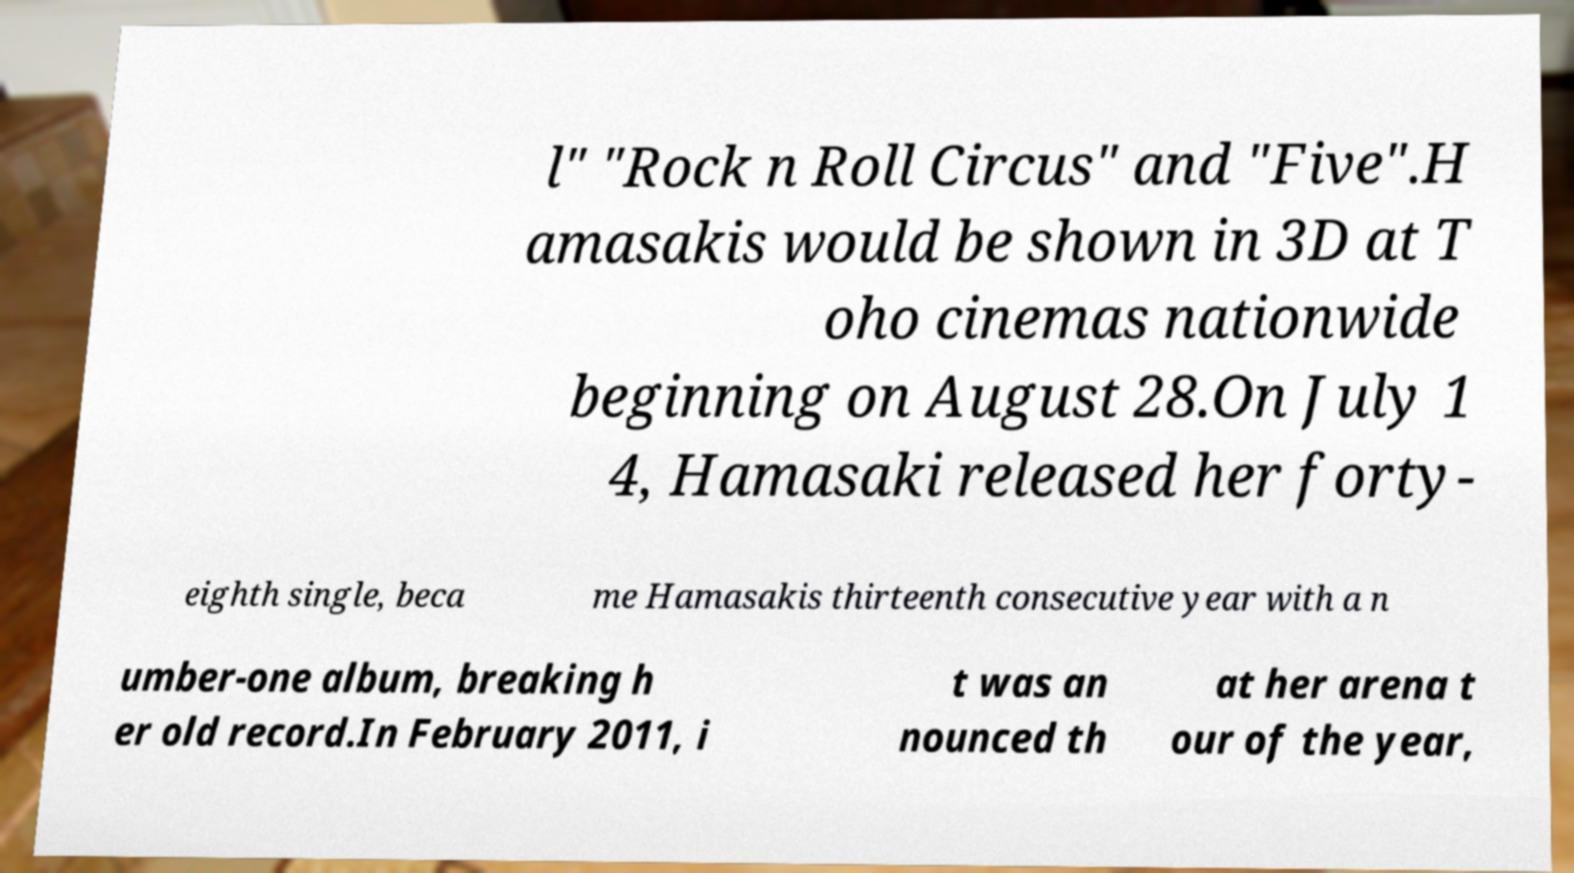For documentation purposes, I need the text within this image transcribed. Could you provide that? l" "Rock n Roll Circus" and "Five".H amasakis would be shown in 3D at T oho cinemas nationwide beginning on August 28.On July 1 4, Hamasaki released her forty- eighth single, beca me Hamasakis thirteenth consecutive year with a n umber-one album, breaking h er old record.In February 2011, i t was an nounced th at her arena t our of the year, 